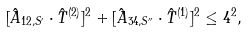<formula> <loc_0><loc_0><loc_500><loc_500>[ \hat { A } _ { 1 2 , S ^ { \prime } } \cdot \hat { T } ^ { ( 2 ) } ] ^ { 2 } + [ \hat { A } _ { 3 4 , S ^ { \prime \prime } } \cdot \hat { T } ^ { ( 1 ) } ] ^ { 2 } \leq 4 ^ { 2 } ,</formula> 